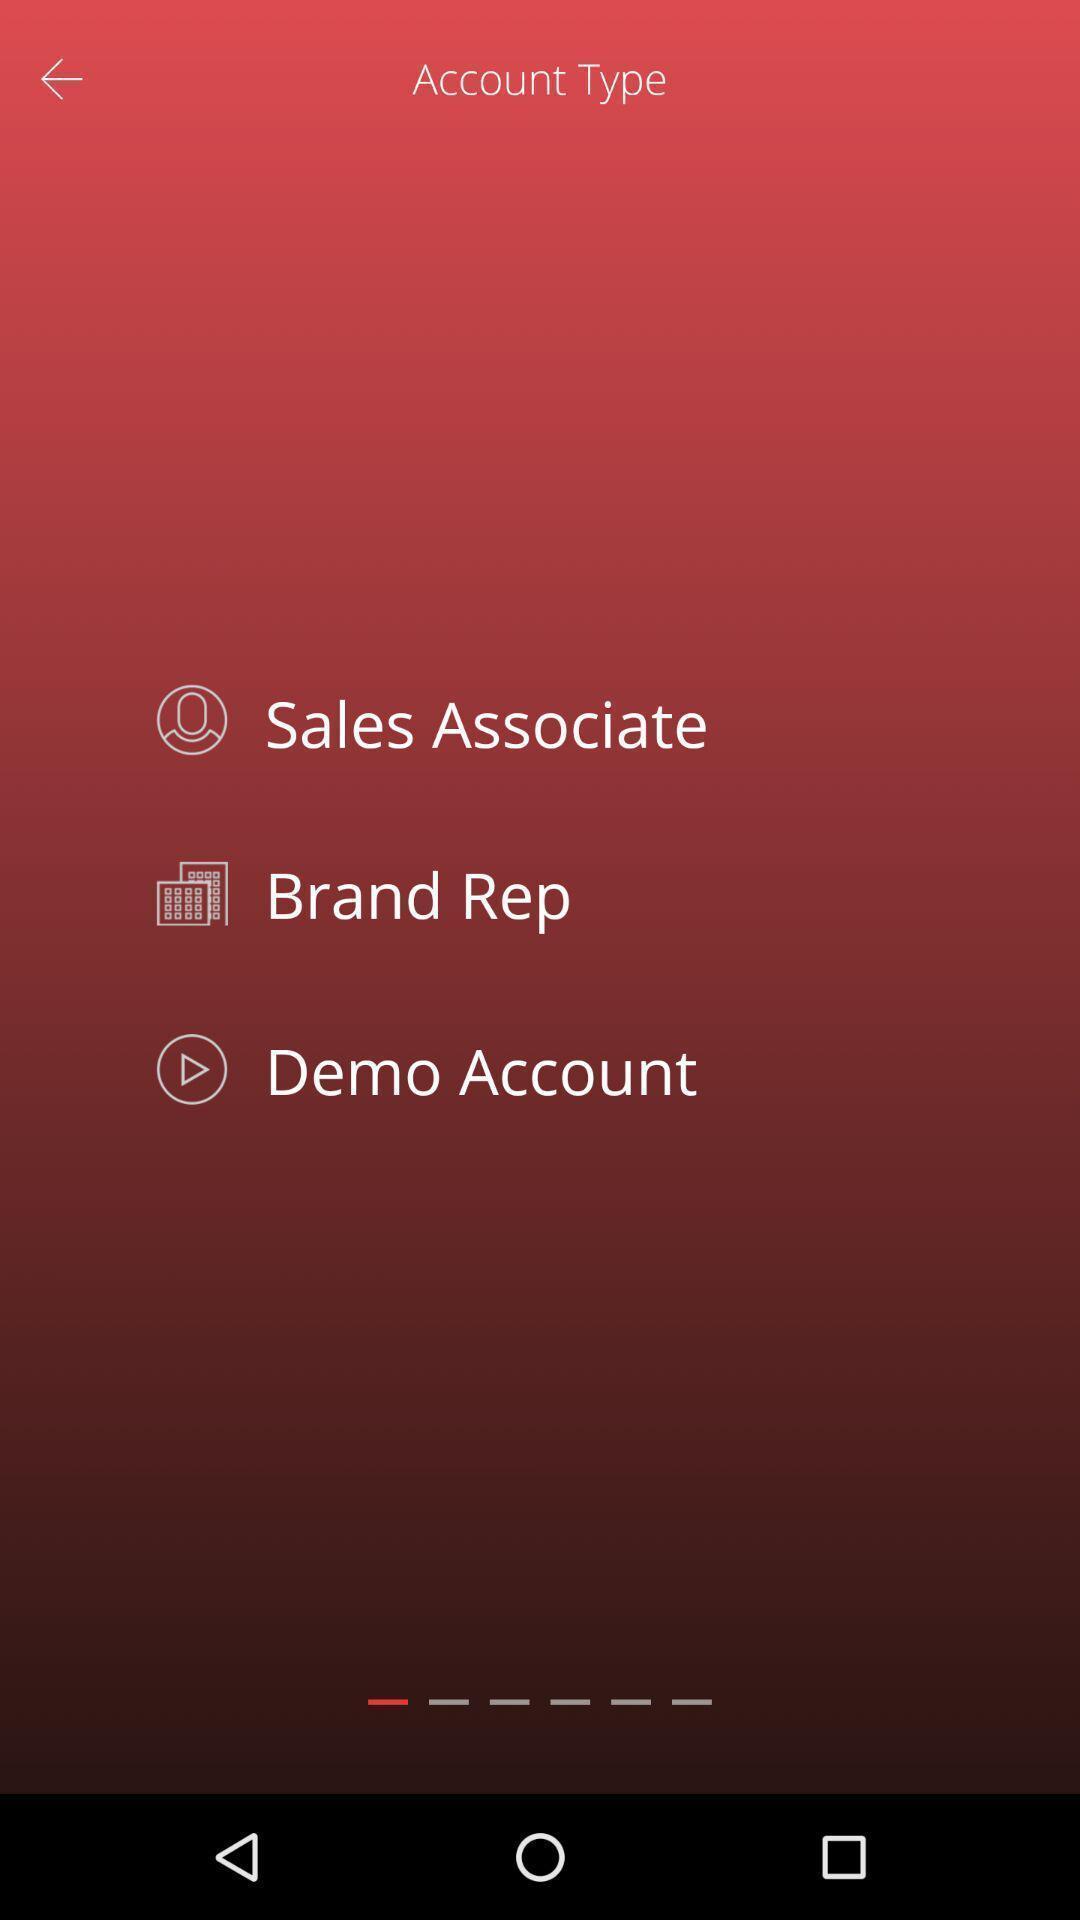Tell me about the visual elements in this screen capture. Page displaying the list of account types. 